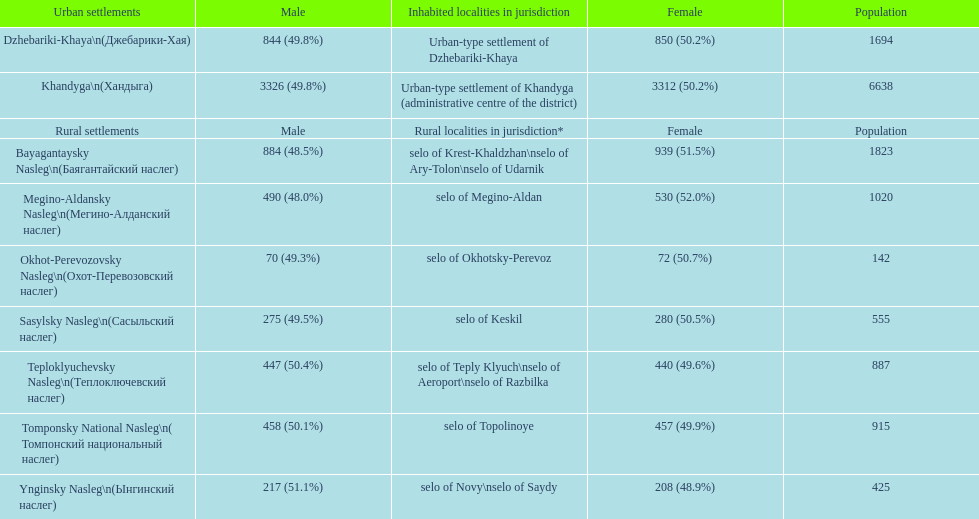How many cities are below 1000 in population? 5. 